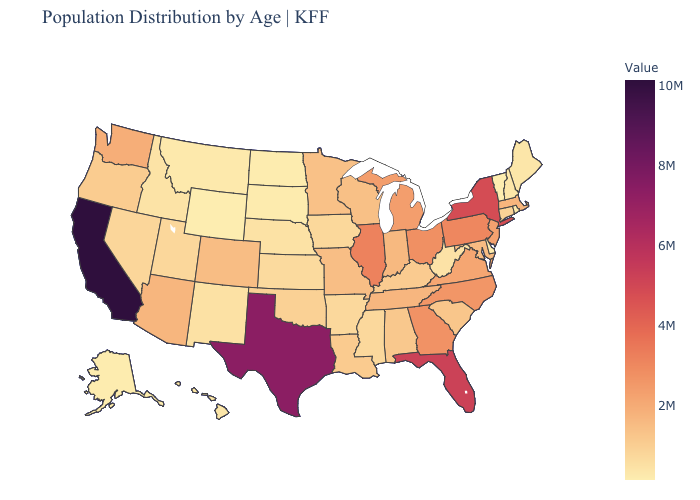Among the states that border Illinois , does Indiana have the lowest value?
Short answer required. No. Which states hav the highest value in the West?
Quick response, please. California. Among the states that border Kentucky , which have the lowest value?
Answer briefly. West Virginia. Which states have the lowest value in the South?
Quick response, please. Delaware. Does Wyoming have the lowest value in the West?
Short answer required. Yes. Does Alabama have a higher value than North Dakota?
Keep it brief. Yes. Among the states that border New Mexico , does Colorado have the lowest value?
Give a very brief answer. No. Is the legend a continuous bar?
Give a very brief answer. Yes. 